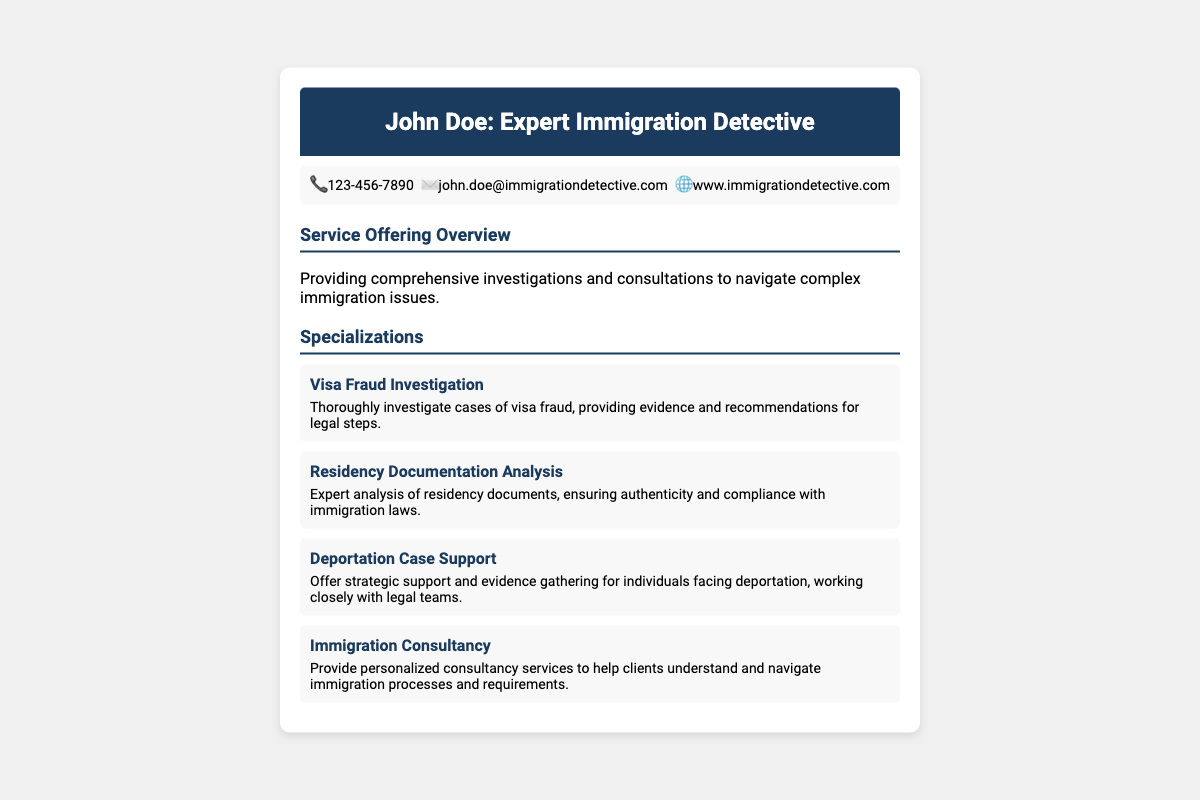what is the name of the expert? The document states the name of the expert as John Doe.
Answer: John Doe what is the phone number listed? The document provides a phone number as part of the contact information.
Answer: 123-456-7890 how many specializations are listed in the document? The document outlines four distinct specializations in total.
Answer: 4 what is the title of the first specialization? The title of the first specialization provided in the document is "Visa Fraud Investigation."
Answer: Visa Fraud Investigation what type of support is offered for deportation cases? The document specifies that strategic support and evidence gathering are offered.
Answer: Strategic support and evidence gathering what is the main focus of the service offering? The service offering overview indicates the focus is on investigations and consultations for immigration issues.
Answer: Investigations and consultations what kind of analysis is provided for residency documentation? The document describes the analysis as ensuring authenticity and compliance with immigration laws.
Answer: Authenticity and compliance analysis what is the email address given in the contact info? The document features an email address for contact purposes as part of the contact information.
Answer: john.doe@immigrationdetective.com what background color is used for the banner? The banner background color is specified in the document.
Answer: #1a3a5e 